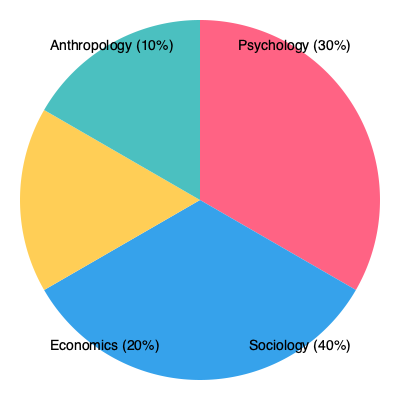In the pie chart showing the distribution of research funding across social science disciplines, which field receives the largest share of funding, and what is the difference in percentage points between the highest and lowest funded disciplines? To answer this question, we need to follow these steps:

1. Identify the largest share of funding:
   - Psychology: 30%
   - Sociology: 40%
   - Economics: 20%
   - Anthropology: 10%

   The largest share is Sociology with 40%.

2. Identify the smallest share of funding:
   The smallest share is Anthropology with 10%.

3. Calculate the difference in percentage points:
   $40\% - 10\% = 30$ percentage points

Therefore, Sociology receives the largest share of funding, and the difference between the highest (Sociology) and lowest (Anthropology) funded disciplines is 30 percentage points.
Answer: Sociology; 30 percentage points 